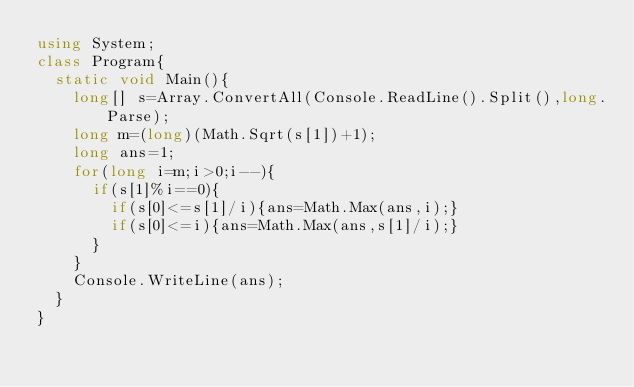Convert code to text. <code><loc_0><loc_0><loc_500><loc_500><_C#_>using System;
class Program{
	static void Main(){
		long[] s=Array.ConvertAll(Console.ReadLine().Split(),long.Parse);
		long m=(long)(Math.Sqrt(s[1])+1);
		long ans=1;
		for(long i=m;i>0;i--){
			if(s[1]%i==0){
				if(s[0]<=s[1]/i){ans=Math.Max(ans,i);}
				if(s[0]<=i){ans=Math.Max(ans,s[1]/i);}
			}
		}
		Console.WriteLine(ans);
	}
}</code> 